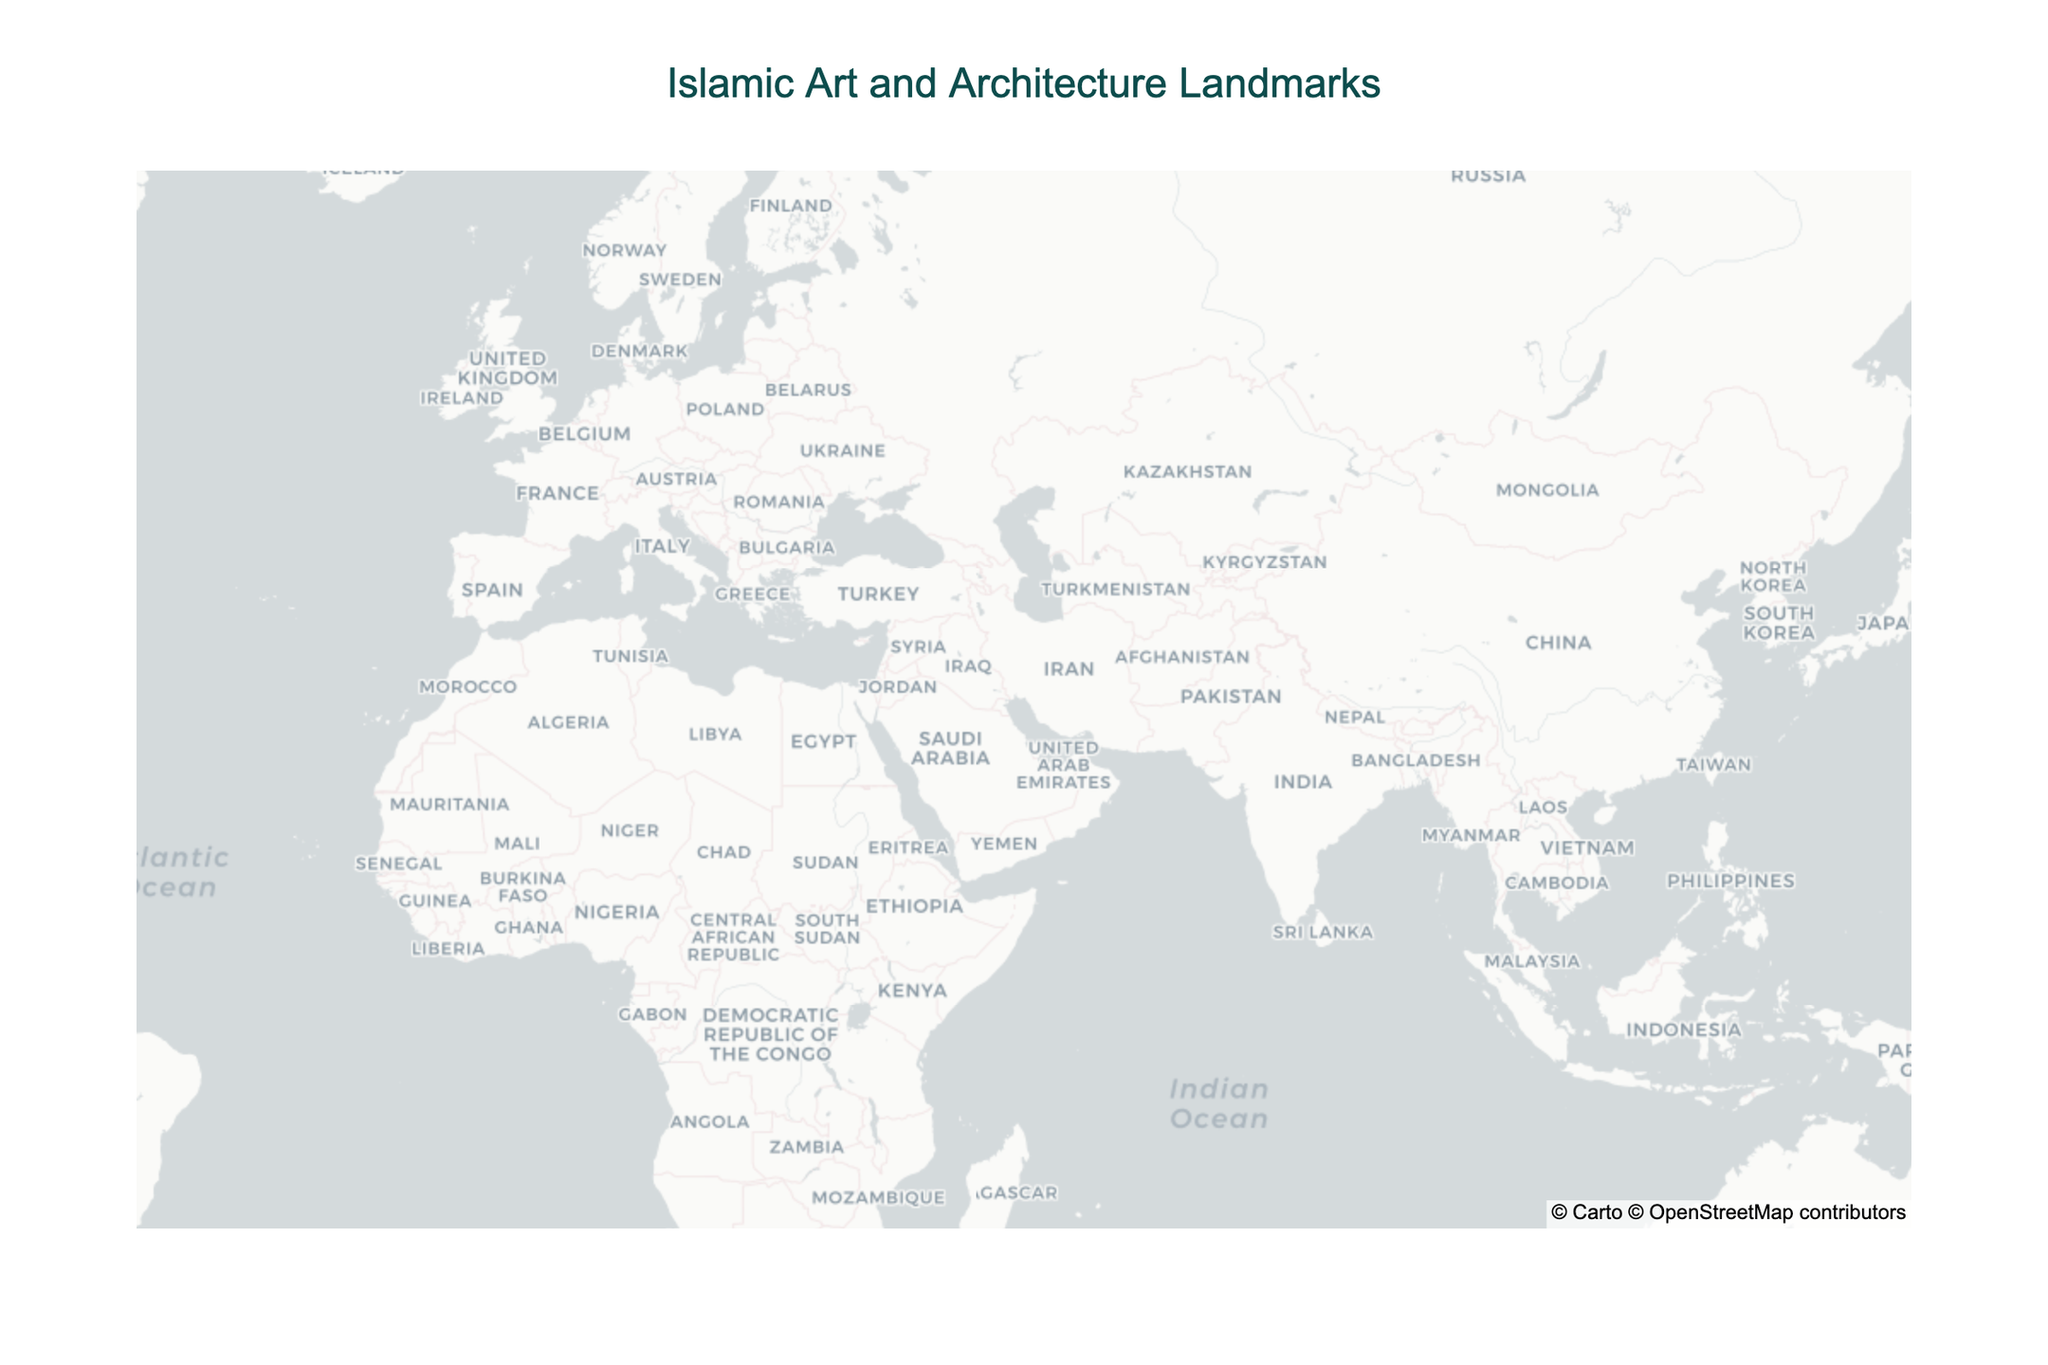What is the title of the figure? The title is usually located at the top of the figure. In this case, it reads "Islamic Art and Architecture Landmarks".
Answer: Islamic Art and Architecture Landmarks Which landmark is located in Agra, India? By identifying and locating the city of Agra, India on the map, we find that the landmark is the Taj Mahal.
Answer: Taj Mahal How many Islamic landmarks are displayed in the figure? Count each unique marker in the figure. The dataset includes 14 landmarks, so there should be 14 markers on the map.
Answer: 14 Which cities have more than one landmark? By examining the markers and their labels on the map, we find that Istanbul, Turkey has multiple landmarks: the Blue Mosque, Hagia Sophia, and Sultan Ahmed Mosque.
Answer: Istanbul Which landmark is located at the southernmost point? By comparing the latitudes on the map, the southernmost landmark is the Great Mosque of Kairouan in Tunisia, with a latitude of 35.6804.
Answer: Great Mosque of Kairouan Are there more landmarks in the Middle East or South Asia? By counting the landmarks in the Middle East (Jerusalem, Mecca, Medina, Abu Dhabi, Isfahan) and comparing them with those in South Asia (Agra, Lahore), we find there are more in the Middle East. Middle East: 6, South Asia: 2.
Answer: Middle East Which landmark has the highest latitude? Sorting by latitude, the Blue Mosque in Istanbul, Turkey (41.0054) has the highest latitude.
Answer: Blue Mosque What is the significance of the Prophets' Mosque in Medina, Saudi Arabia? By locating the Prophets' Mosque in Medina on the map and referring to the significance listed, it is identified as the "Second holiest site in Islam".
Answer: Second holiest site in Islam Is the landmark in Abu Dhabi larger than the one in Lahore? By comparing the significance descriptions from the hover information, Sheikh Zayed Mosque in Abu Dhabi is described as "Largest mosque in UAE" whereas Badshahi Mosque in Lahore is "Largest Mughal-era mosque". Without size measurements, this comparison relies on the descriptions' context implying Abu Dhabi’s landmark could be larger.
Answer: Yes Which landmark is located near the area of 21.4225 latitude and 39.8262 longitude? By cross-referencing the coordinates, Masjid al-Haram in Mecca, Saudi Arabia is located at the given latitude and longitude.
Answer: Masjid al-Haram 